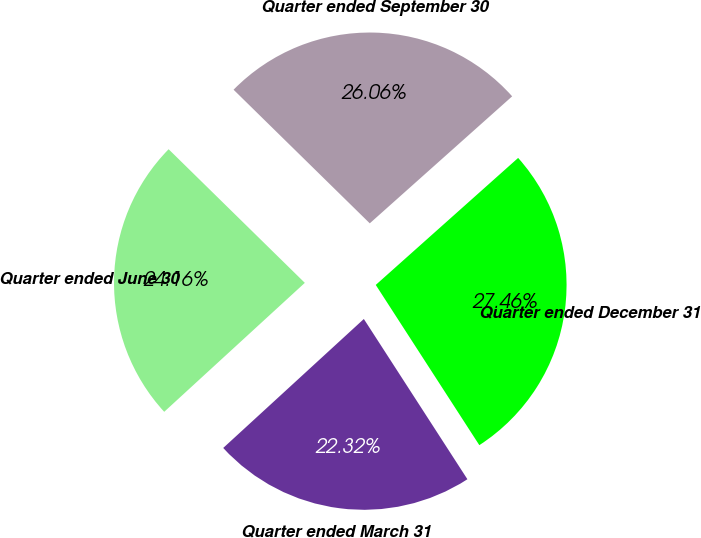Convert chart. <chart><loc_0><loc_0><loc_500><loc_500><pie_chart><fcel>Quarter ended March 31<fcel>Quarter ended June 30<fcel>Quarter ended September 30<fcel>Quarter ended December 31<nl><fcel>22.32%<fcel>24.16%<fcel>26.06%<fcel>27.46%<nl></chart> 